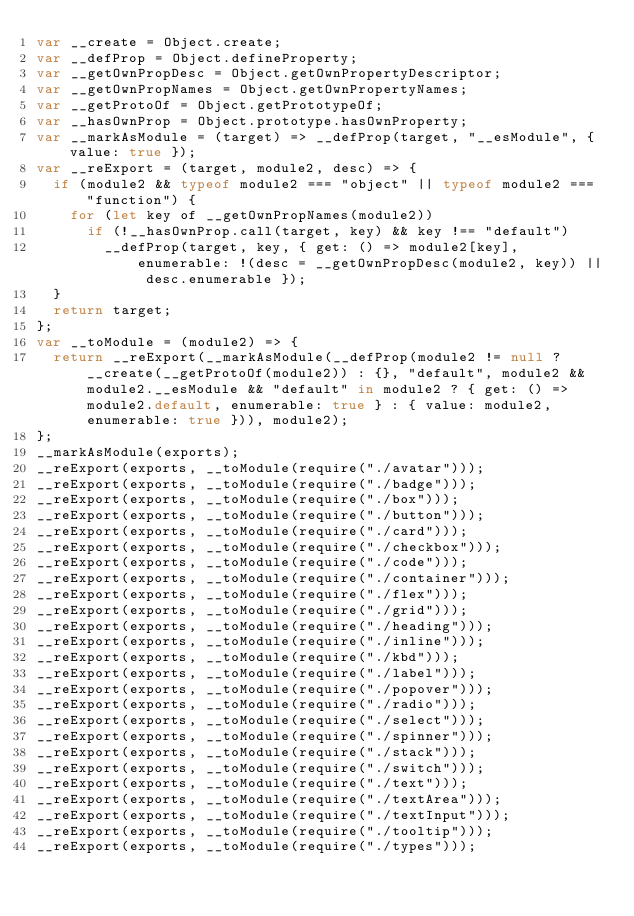<code> <loc_0><loc_0><loc_500><loc_500><_JavaScript_>var __create = Object.create;
var __defProp = Object.defineProperty;
var __getOwnPropDesc = Object.getOwnPropertyDescriptor;
var __getOwnPropNames = Object.getOwnPropertyNames;
var __getProtoOf = Object.getPrototypeOf;
var __hasOwnProp = Object.prototype.hasOwnProperty;
var __markAsModule = (target) => __defProp(target, "__esModule", { value: true });
var __reExport = (target, module2, desc) => {
  if (module2 && typeof module2 === "object" || typeof module2 === "function") {
    for (let key of __getOwnPropNames(module2))
      if (!__hasOwnProp.call(target, key) && key !== "default")
        __defProp(target, key, { get: () => module2[key], enumerable: !(desc = __getOwnPropDesc(module2, key)) || desc.enumerable });
  }
  return target;
};
var __toModule = (module2) => {
  return __reExport(__markAsModule(__defProp(module2 != null ? __create(__getProtoOf(module2)) : {}, "default", module2 && module2.__esModule && "default" in module2 ? { get: () => module2.default, enumerable: true } : { value: module2, enumerable: true })), module2);
};
__markAsModule(exports);
__reExport(exports, __toModule(require("./avatar")));
__reExport(exports, __toModule(require("./badge")));
__reExport(exports, __toModule(require("./box")));
__reExport(exports, __toModule(require("./button")));
__reExport(exports, __toModule(require("./card")));
__reExport(exports, __toModule(require("./checkbox")));
__reExport(exports, __toModule(require("./code")));
__reExport(exports, __toModule(require("./container")));
__reExport(exports, __toModule(require("./flex")));
__reExport(exports, __toModule(require("./grid")));
__reExport(exports, __toModule(require("./heading")));
__reExport(exports, __toModule(require("./inline")));
__reExport(exports, __toModule(require("./kbd")));
__reExport(exports, __toModule(require("./label")));
__reExport(exports, __toModule(require("./popover")));
__reExport(exports, __toModule(require("./radio")));
__reExport(exports, __toModule(require("./select")));
__reExport(exports, __toModule(require("./spinner")));
__reExport(exports, __toModule(require("./stack")));
__reExport(exports, __toModule(require("./switch")));
__reExport(exports, __toModule(require("./text")));
__reExport(exports, __toModule(require("./textArea")));
__reExport(exports, __toModule(require("./textInput")));
__reExport(exports, __toModule(require("./tooltip")));
__reExport(exports, __toModule(require("./types")));
</code> 